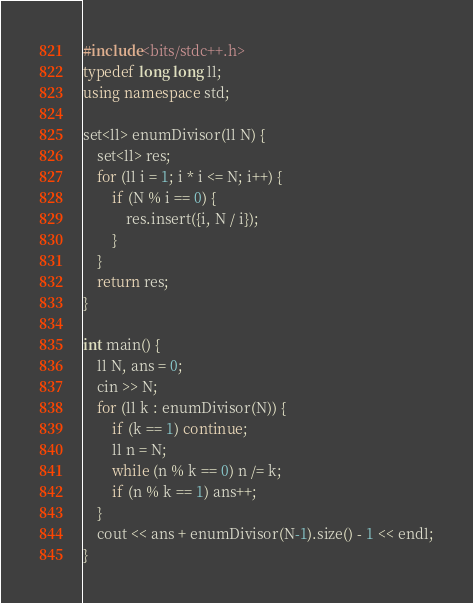Convert code to text. <code><loc_0><loc_0><loc_500><loc_500><_C++_>#include<bits/stdc++.h>
typedef long long ll;
using namespace std;

set<ll> enumDivisor(ll N) {
    set<ll> res;
    for (ll i = 1; i * i <= N; i++) {
        if (N % i == 0) {
            res.insert({i, N / i});
        }
    }
    return res;
}

int main() {
    ll N, ans = 0;
    cin >> N;
    for (ll k : enumDivisor(N)) {
        if (k == 1) continue;
        ll n = N;
        while (n % k == 0) n /= k;
        if (n % k == 1) ans++;
    }
    cout << ans + enumDivisor(N-1).size() - 1 << endl;
}</code> 